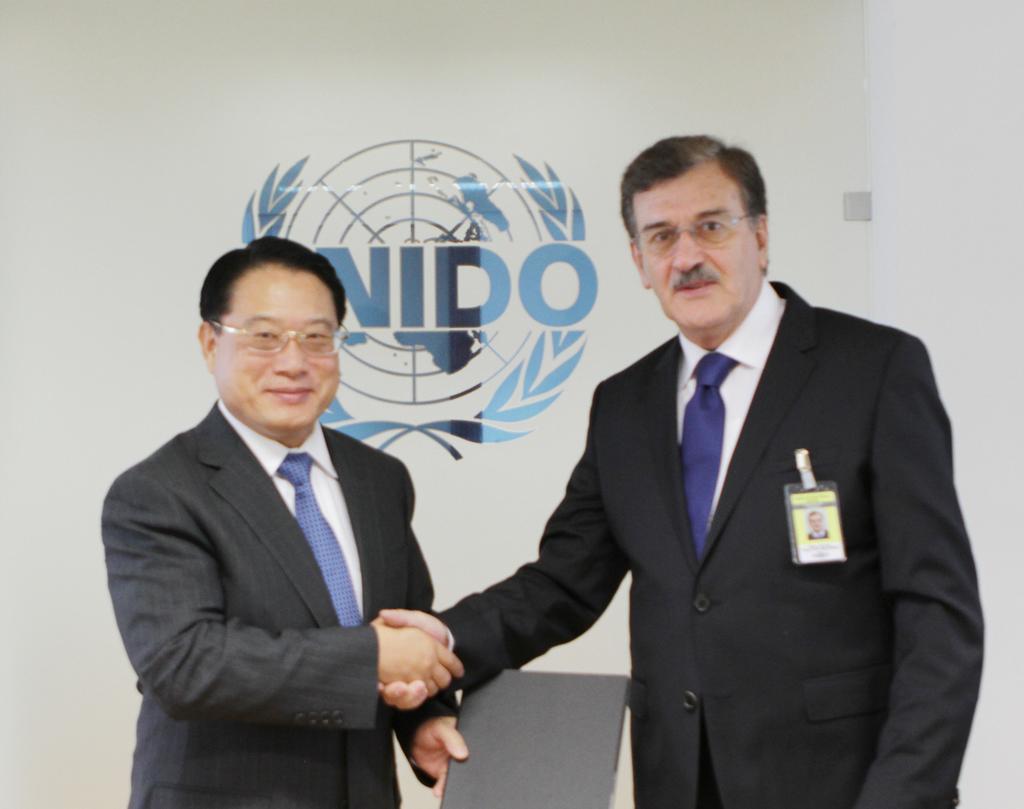Please provide a concise description of this image. In this picture there is a man who is wearing spectacle, blazer, shirt, tie and ID card. Beside him we can see another man who is wearing spectacle and shoe. Both of them are shaking hands. On the background we can see the banner. This person is holding a file. 